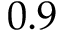<formula> <loc_0><loc_0><loc_500><loc_500>0 . 9</formula> 